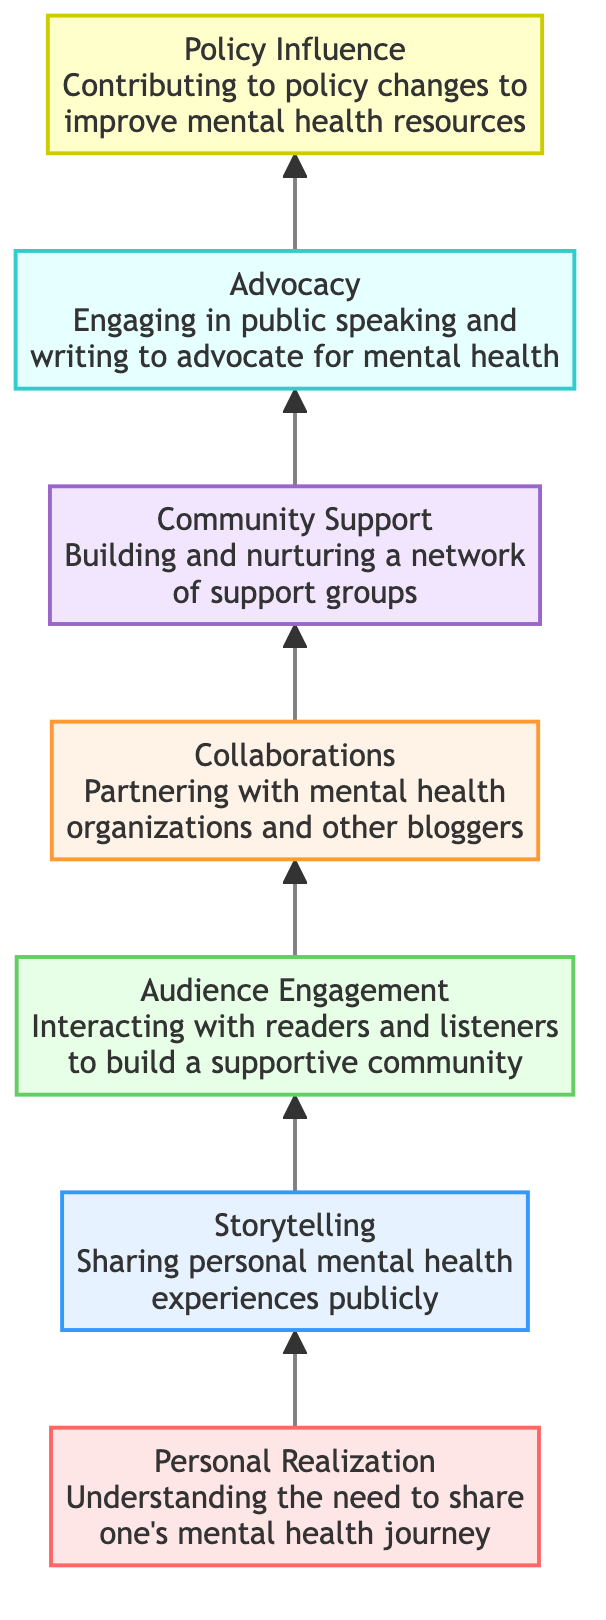What is the first step in the flow chart? According to the diagram, the first step is located at the bottom, which is "Personal Realization." This is represented as the starting point of the flow leading upwards.
Answer: Personal Realization How many levels are there in total? Counting from "Personal Realization" at level 1 to "Policy Influence" at level 7 gives a total of seven levels in this flow chart.
Answer: 7 Which step involves audience interaction? From the flow chart, "Audience Engagement" is the step where interaction with readers and listeners occurs. This node is directly above "Storytelling," indicating the sequence in the process.
Answer: Audience Engagement What is the relationship between "Collaborations" and "Community Support"? "Collaborations" leads directly to "Community Support," indicating that partnering with organizations contributes to building a network of support groups in the next step.
Answer: Directly related Which element comes after "Advocacy"? The flow proceeds upwards from "Advocacy" to "Policy Influence," meaning that the action of advocating leads to the contribution of policy changes.
Answer: Policy Influence What do "Storytelling" and "Collaborations" have in common? Both "Storytelling" and "Collaborations" are part of the process aimed at mental health stigma reduction, acting as crucial steps that contribute to community-building and awareness efforts, though at different levels in the sequence.
Answer: Both contribute to stigma reduction How does "Community Support" relate to the overall goal of the diagram? "Community Support" is a key step in the flow, as it builds and nurtures networks of support that are vital for reducing mental health stigma, linking personal stories to broader societal change.
Answer: Vital step for stigma reduction Which level corresponds to engaging in public speaking? "Advocacy," located at level 6, corresponds to the action of engaging in public speaking to promote mental health awareness and initiatives, serving as a significant action in the flow.
Answer: Level 6 